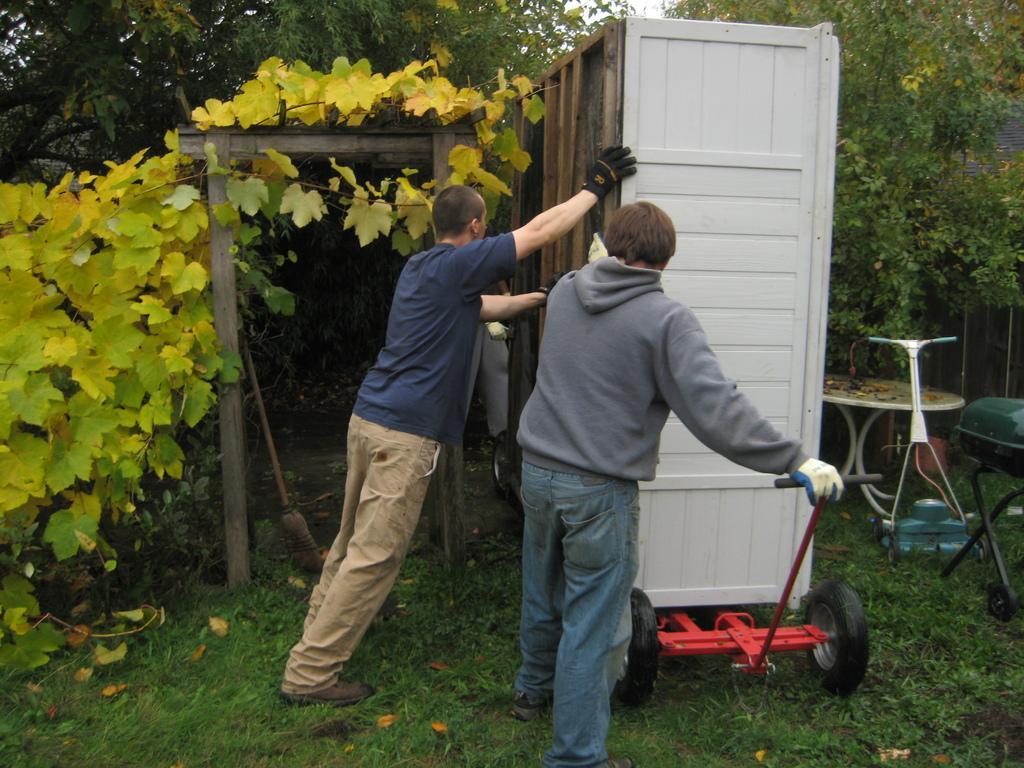Could you give a brief overview of what you see in this image? In this image there are two people pushing the wooden object on the trolley. On the right side of the image there is a table and there are a few other objects. At the bottom of the image there is grass on the surface. There is a wooden arch and there is a brush. In the background of the image there are trees. 